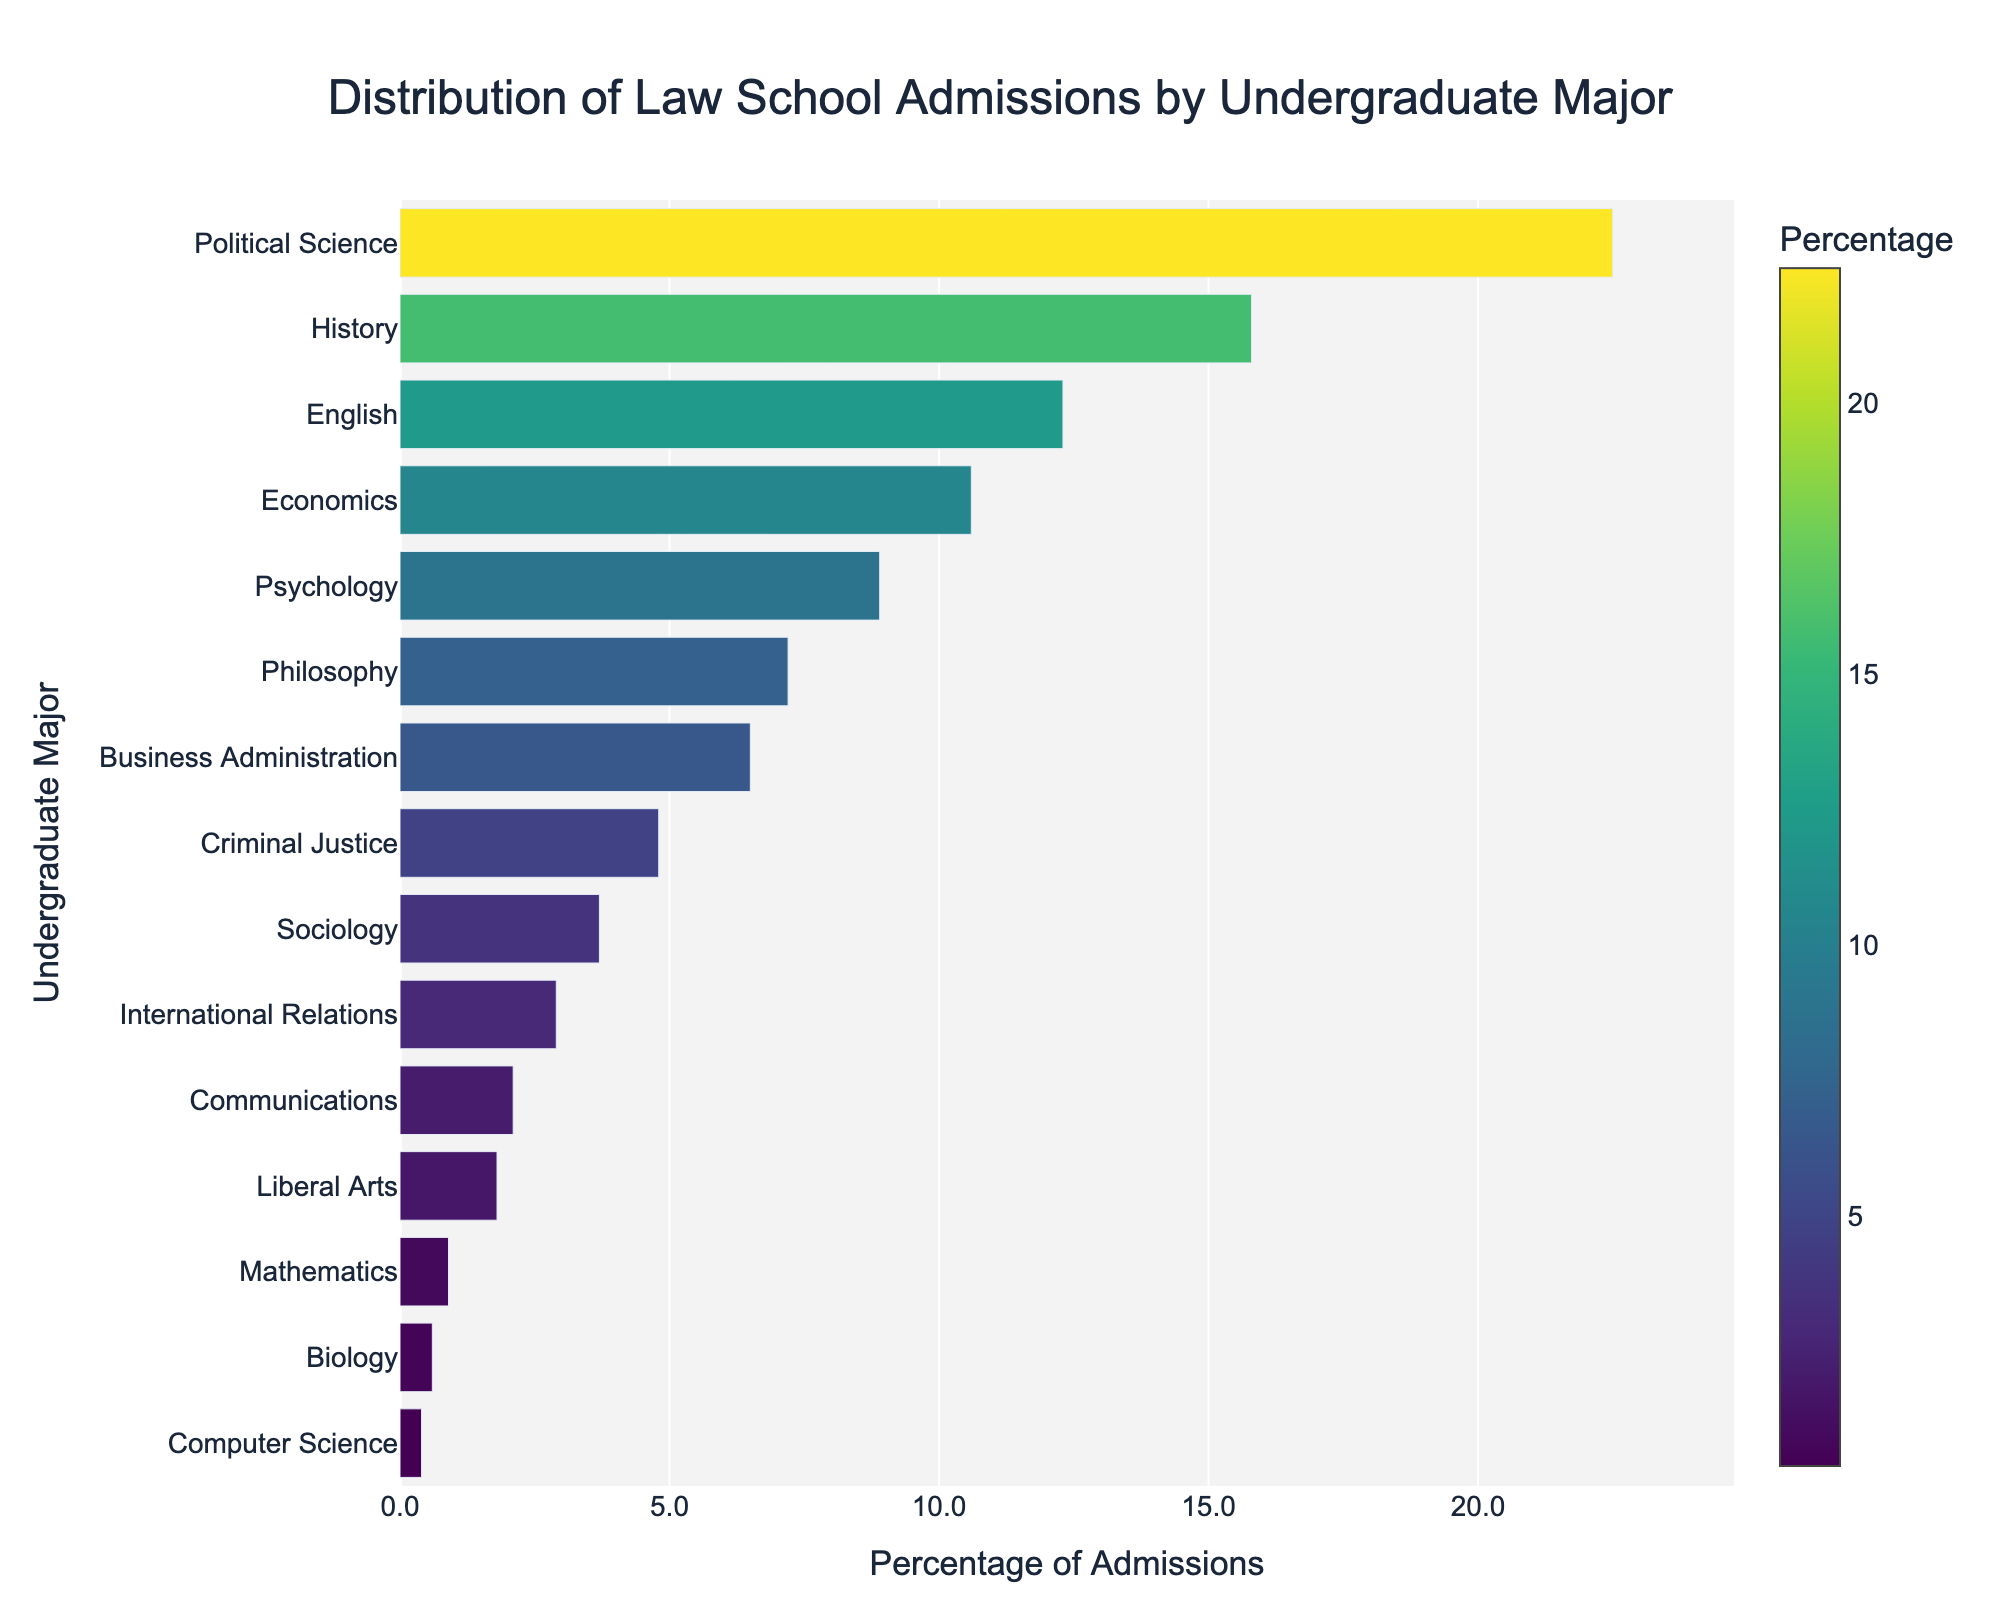What is the most common undergraduate major for law school admissions? The figure shows that "Political Science" has the highest percentage among undergraduate majors admitted to law school.
Answer: Political Science What is the total percentage of law school admissions coming from Political Science and History majors? Add the percentage of Political Science (22.5%) and History (15.8%). The sum is 22.5 + 15.8 = 38.3%.
Answer: 38.3% Which undergraduate major has a slightly higher percentage of law school admissions, Business Administration or Criminal Justice? Compare the percentages: Business Administration has 6.5%, and Criminal Justice has 4.8%. Therefore, Business Administration is slightly higher.
Answer: Business Administration What percentage of law school admissions comes from both Economics and Psychology majors combined? Add the percentages of Economics (10.6%) and Psychology (8.9%). The sum is 10.6 + 8.9 = 19.5%.
Answer: 19.5% How much higher is the percentage of law school admissions from English majors compared to Computer Science majors? Subtract the percentage of Computer Science (0.4%) from the percentage of English (12.3%). The difference is 12.3 - 0.4 = 11.9%.
Answer: 11.9% Which majors have an admissions percentage between 5% and 10%? The figure shows that Economics (10.6%), Psychology (8.9%), Philosophy (7.2%), and Business Administration (6.5%) all fall between 5% and 10%.
Answer: Economics, Psychology, Philosophy, Business Administration How does the height of the bar for Mathematics compare to that of History? The bar for History is much taller (15.8%) compared to the bar for Mathematics (0.9%), indicating a significant difference in percentages.
Answer: History is much taller What is the combined percentage of law school admissions from majors that contribute less than 1% each? Add the percentages of majors contributing less than 1%: Mathematics (0.9%), Biology (0.6%), and Computer Science (0.4%). The sum is 0.9 + 0.6 + 0.4 = 1.9%.
Answer: 1.9% What is the percentage difference between the highest and the lowest majors in law school admissions? Subtract the percentage of Computer Science (0.4%) from Political Science (22.5%). The difference is 22.5 - 0.4 = 22.1%.
Answer: 22.1% Which major contributes slightly under 5% to law school admissions? The major that contributes 4.8%, which is slightly under 5%, is Criminal Justice.
Answer: Criminal Justice 